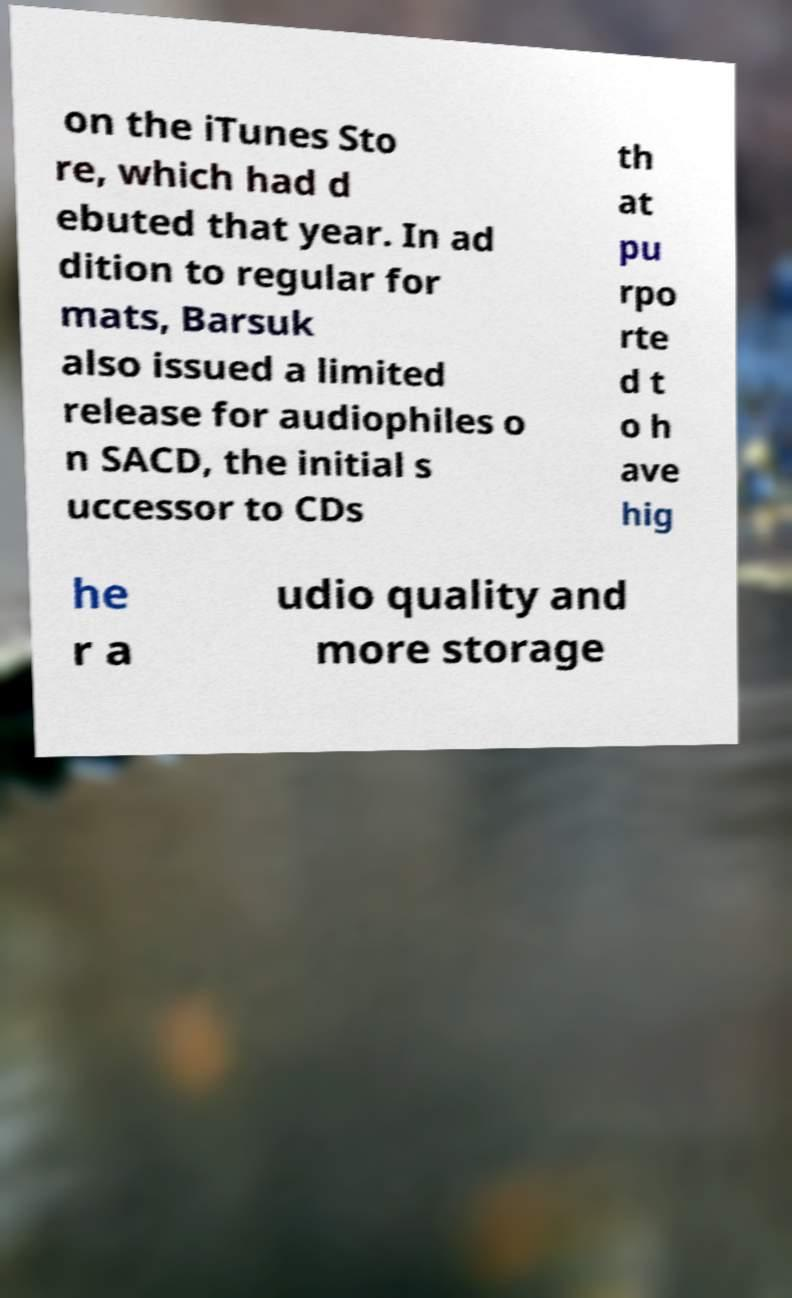Please read and relay the text visible in this image. What does it say? on the iTunes Sto re, which had d ebuted that year. In ad dition to regular for mats, Barsuk also issued a limited release for audiophiles o n SACD, the initial s uccessor to CDs th at pu rpo rte d t o h ave hig he r a udio quality and more storage 